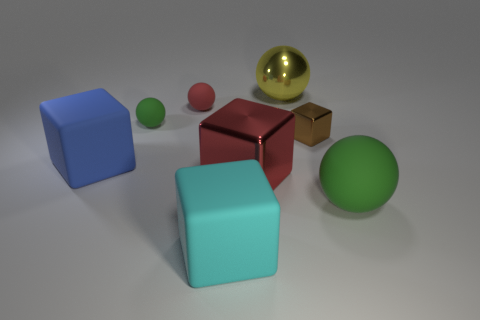Are there more green things in front of the large metal cube than green things in front of the large blue rubber block?
Give a very brief answer. No. How many other objects are there of the same color as the big shiny ball?
Offer a very short reply. 0. Does the large metal cube have the same color as the big ball that is right of the yellow sphere?
Ensure brevity in your answer.  No. There is a small matte object that is right of the small green matte object; what number of blue objects are behind it?
Your answer should be very brief. 0. Is there anything else that is the same material as the red block?
Your response must be concise. Yes. What material is the green object to the right of the big ball that is behind the green rubber sphere left of the big yellow object?
Offer a very short reply. Rubber. What is the sphere that is to the right of the big red block and behind the brown cube made of?
Offer a terse response. Metal. How many blue things have the same shape as the cyan matte thing?
Your answer should be compact. 1. What is the size of the green ball that is to the right of the small green object that is on the left side of the cyan block?
Offer a very short reply. Large. There is a large sphere on the left side of the brown block; is its color the same as the large sphere that is right of the small metallic thing?
Your response must be concise. No. 